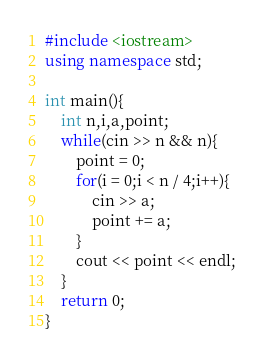<code> <loc_0><loc_0><loc_500><loc_500><_C++_>#include <iostream>
using namespace std;

int main(){
	int n,i,a,point;
	while(cin >> n && n){
		point = 0;
		for(i = 0;i < n / 4;i++){
			cin >> a;
			point += a;
		}
		cout << point << endl;
	}
	return 0;
}</code> 